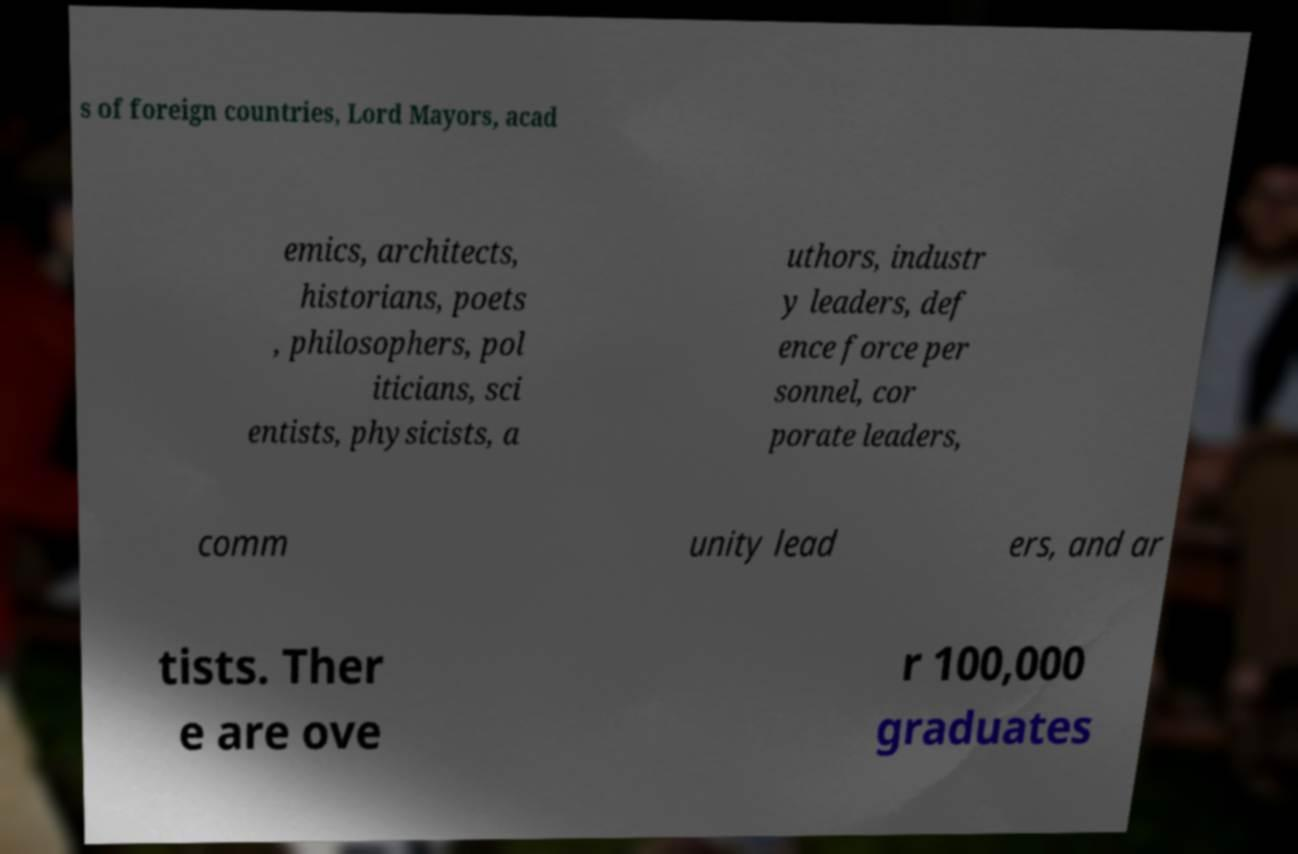What messages or text are displayed in this image? I need them in a readable, typed format. s of foreign countries, Lord Mayors, acad emics, architects, historians, poets , philosophers, pol iticians, sci entists, physicists, a uthors, industr y leaders, def ence force per sonnel, cor porate leaders, comm unity lead ers, and ar tists. Ther e are ove r 100,000 graduates 